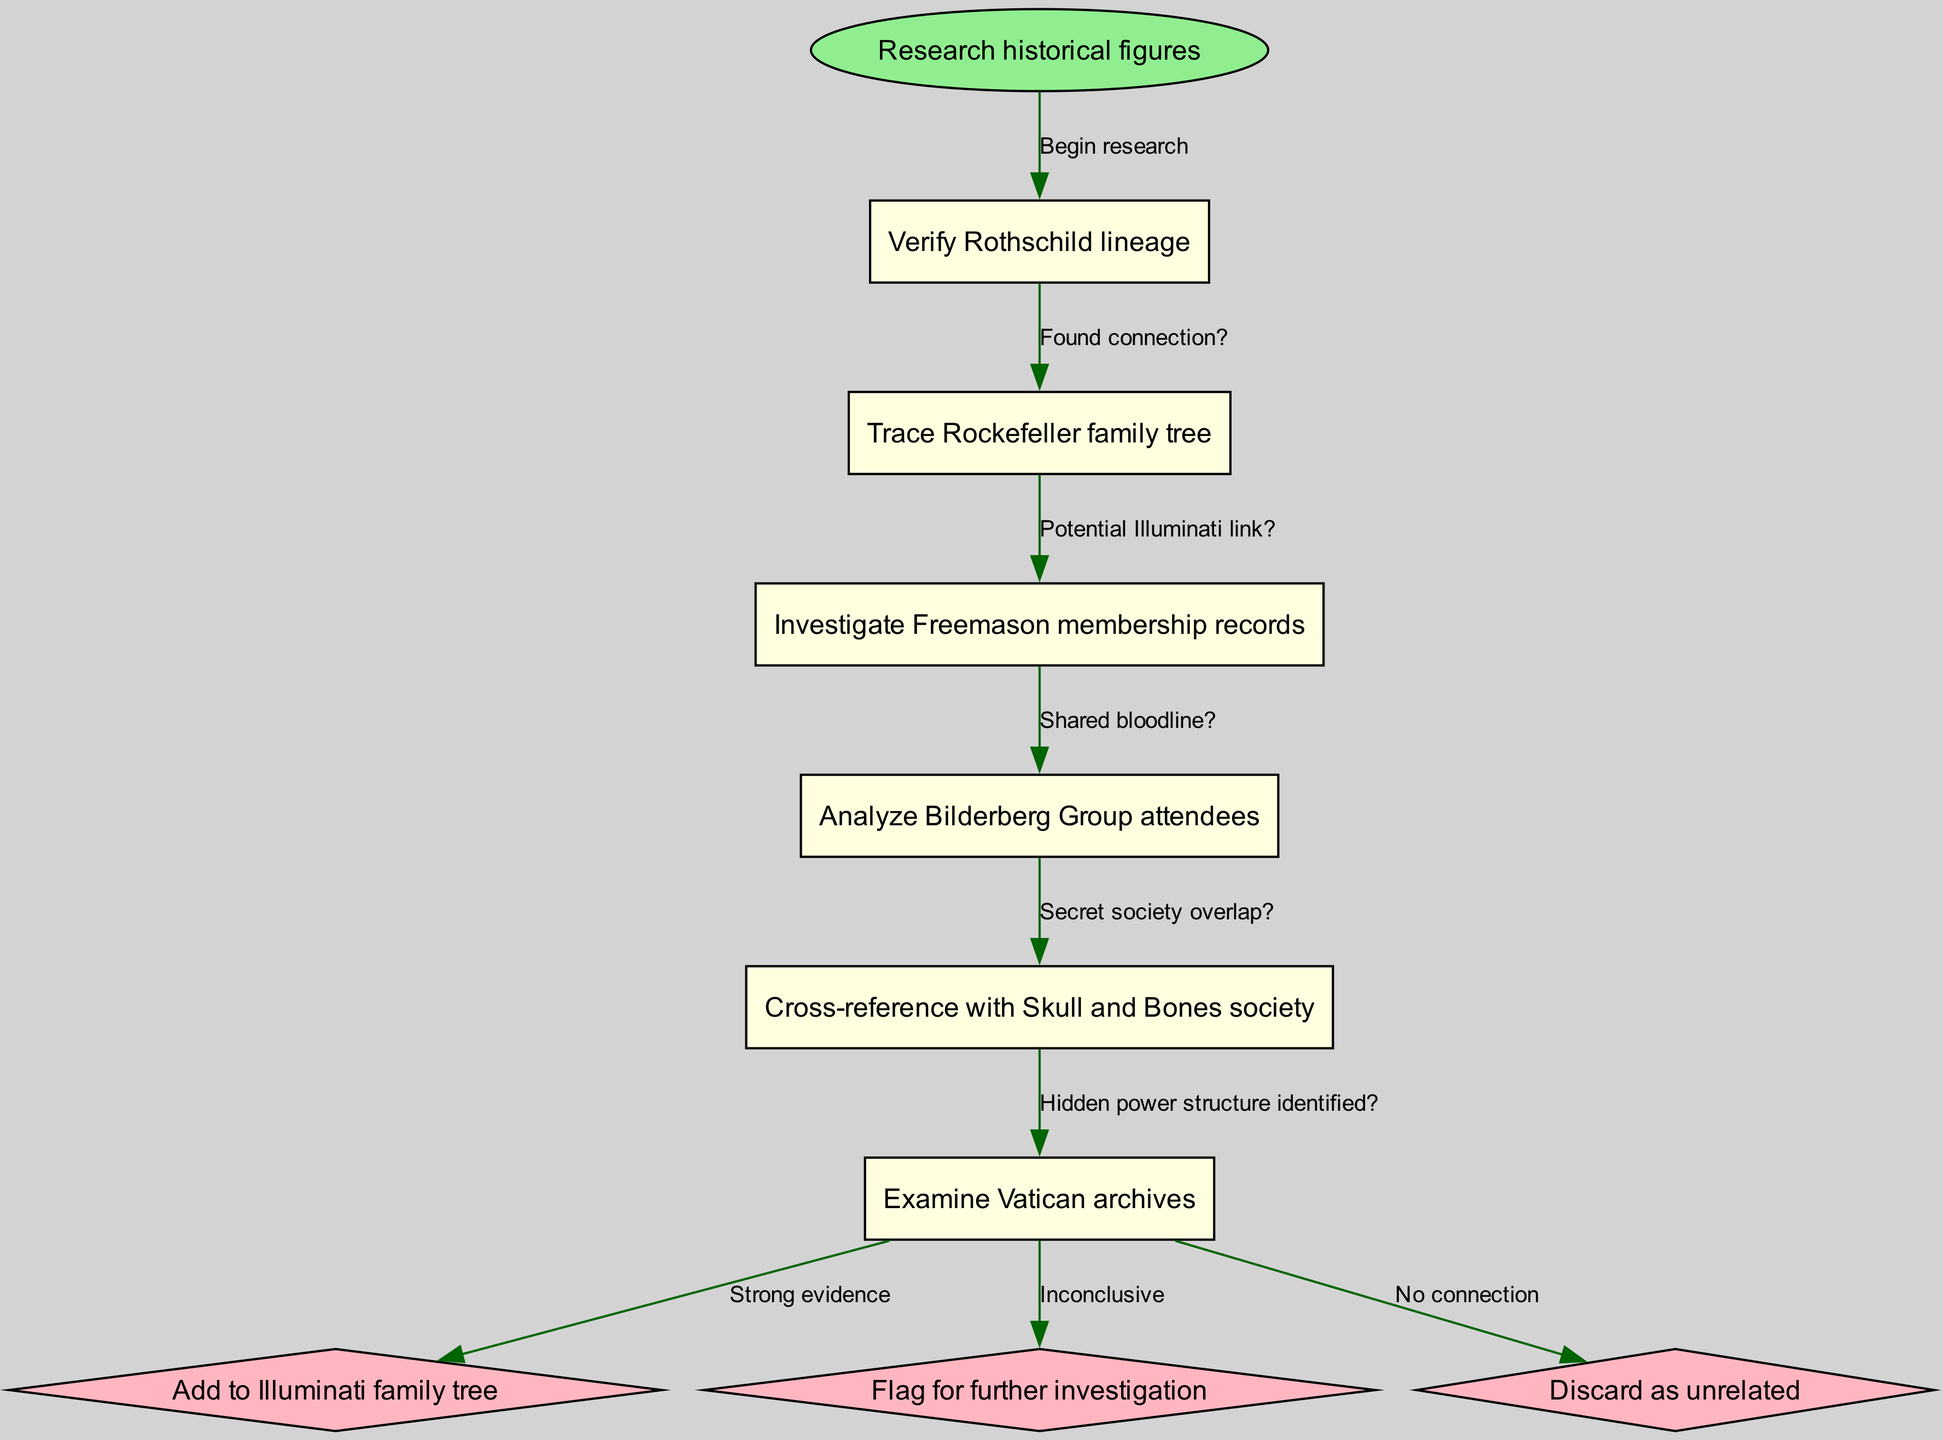What is the starting point of the flowchart? The start node is labeled "Research historical figures," which indicates where the flow begins.
Answer: Research historical figures How many main nodes are present in the diagram? There are six main nodes listed under "nodes," which represent different historical research tasks.
Answer: 6 What is the shape of the starting node? The starting node is shaped as an ellipse, which is commonly used to signify the entry point in flowcharts.
Answer: ellipse What is the last node before reaching the end nodes? The last main node before the end nodes is "Examine Vatican archives," as it is the final task outlined.
Answer: Examine Vatican archives Which edge connects to the first end node? The edge that connects the last main node, "Examine Vatican archives," to the first end node, labeled "Add to Illuminati family tree," indicates the outcome with strong evidence.
Answer: Strong evidence How does "Trace Rockefeller family tree" lead to the next node? After "Trace Rockefeller family tree," the edge labeled "Potential Illuminati link?" leads to the subsequent node, indicating the logic flow for verification.
Answer: Potential Illuminati link? What type of connection is represented by the edge between last main node and second end node? The connection from "Examine Vatican archives" to the second end node, "Flag for further investigation," illustrates an inconclusive relation requiring more scrutiny.
Answer: Inconclusive What is the total number of edges in the diagram? The diagram connects nodes using five edges, as indicated by the relationships amongst the main nodes before reaching end nodes.
Answer: 5 Which node deals with Freemason records? The main node designated for examining organization affiliations is "Investigate Freemason membership records," which specifically relates to that society.
Answer: Investigate Freemason membership records 